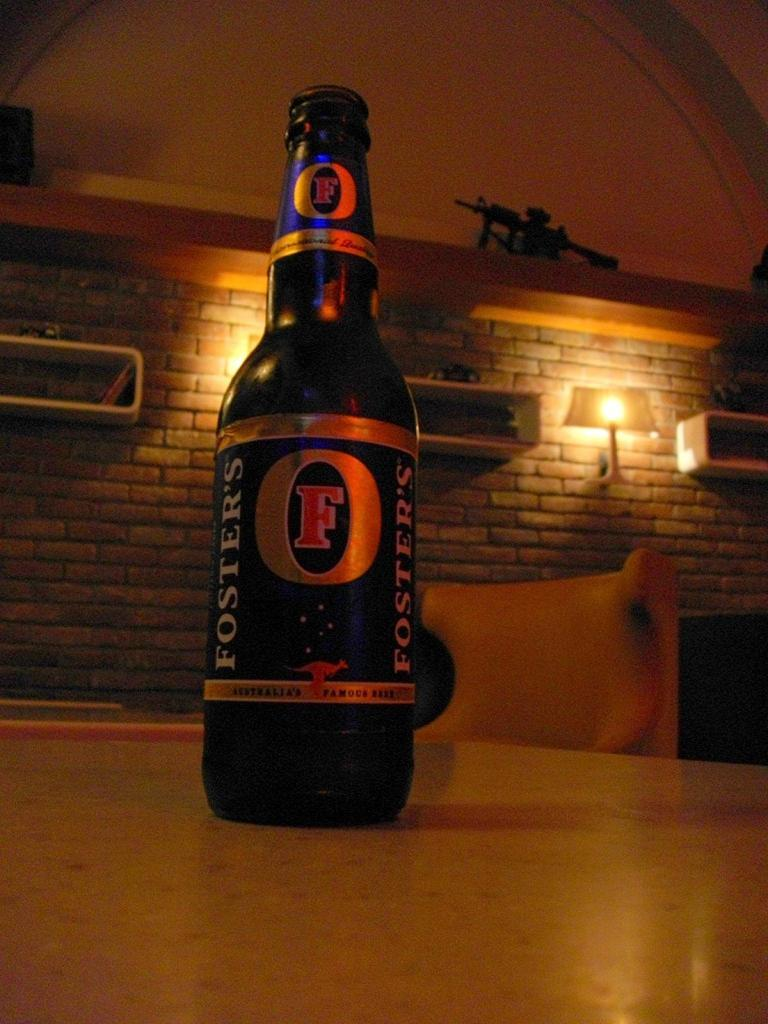<image>
Present a compact description of the photo's key features. A bottle of Foster's sits on a table in a dimly lit area with a brick wall in the distance. 